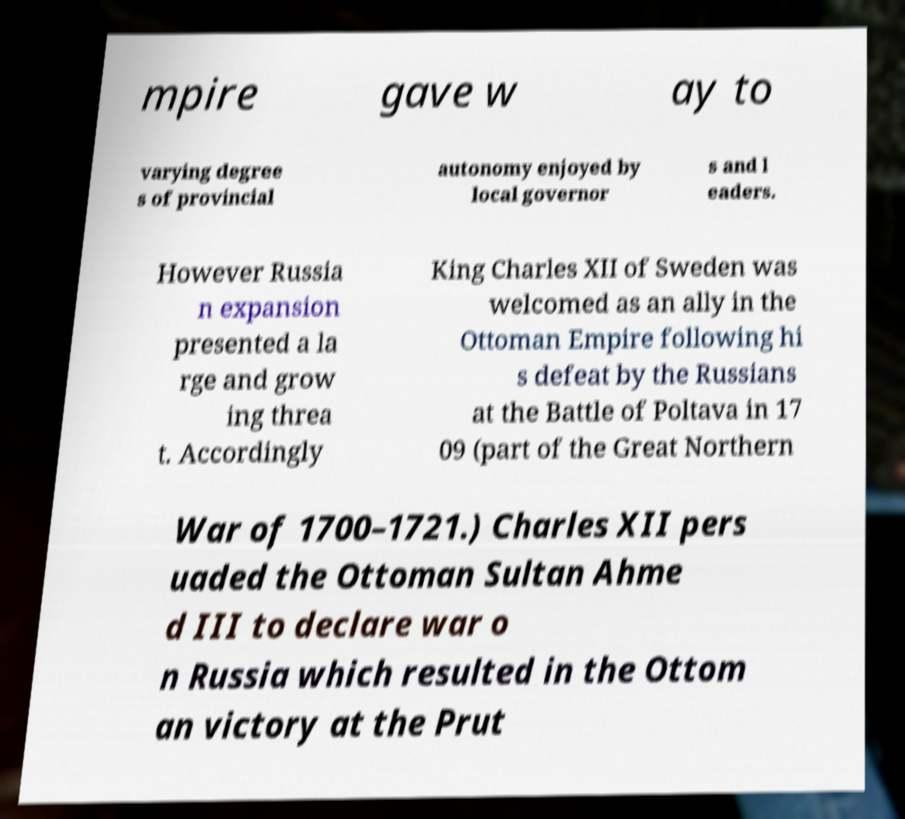For documentation purposes, I need the text within this image transcribed. Could you provide that? mpire gave w ay to varying degree s of provincial autonomy enjoyed by local governor s and l eaders. However Russia n expansion presented a la rge and grow ing threa t. Accordingly King Charles XII of Sweden was welcomed as an ally in the Ottoman Empire following hi s defeat by the Russians at the Battle of Poltava in 17 09 (part of the Great Northern War of 1700–1721.) Charles XII pers uaded the Ottoman Sultan Ahme d III to declare war o n Russia which resulted in the Ottom an victory at the Prut 